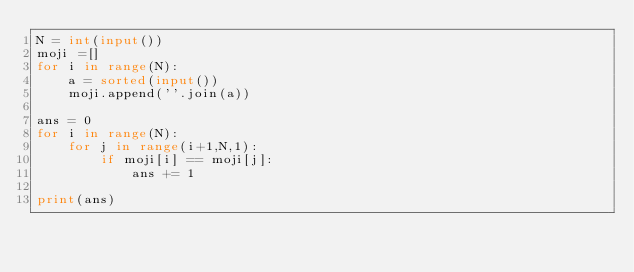Convert code to text. <code><loc_0><loc_0><loc_500><loc_500><_Python_>N = int(input())
moji =[]
for i in range(N):
    a = sorted(input())
    moji.append(''.join(a))

ans = 0
for i in range(N):
    for j in range(i+1,N,1):
        if moji[i] == moji[j]:
            ans += 1

print(ans)

</code> 